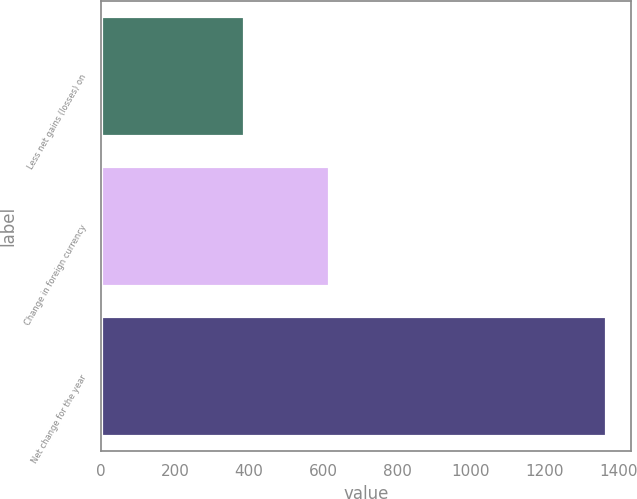<chart> <loc_0><loc_0><loc_500><loc_500><bar_chart><fcel>Less net gains (losses) on<fcel>Change in foreign currency<fcel>Net change for the year<nl><fcel>385<fcel>615<fcel>1366<nl></chart> 